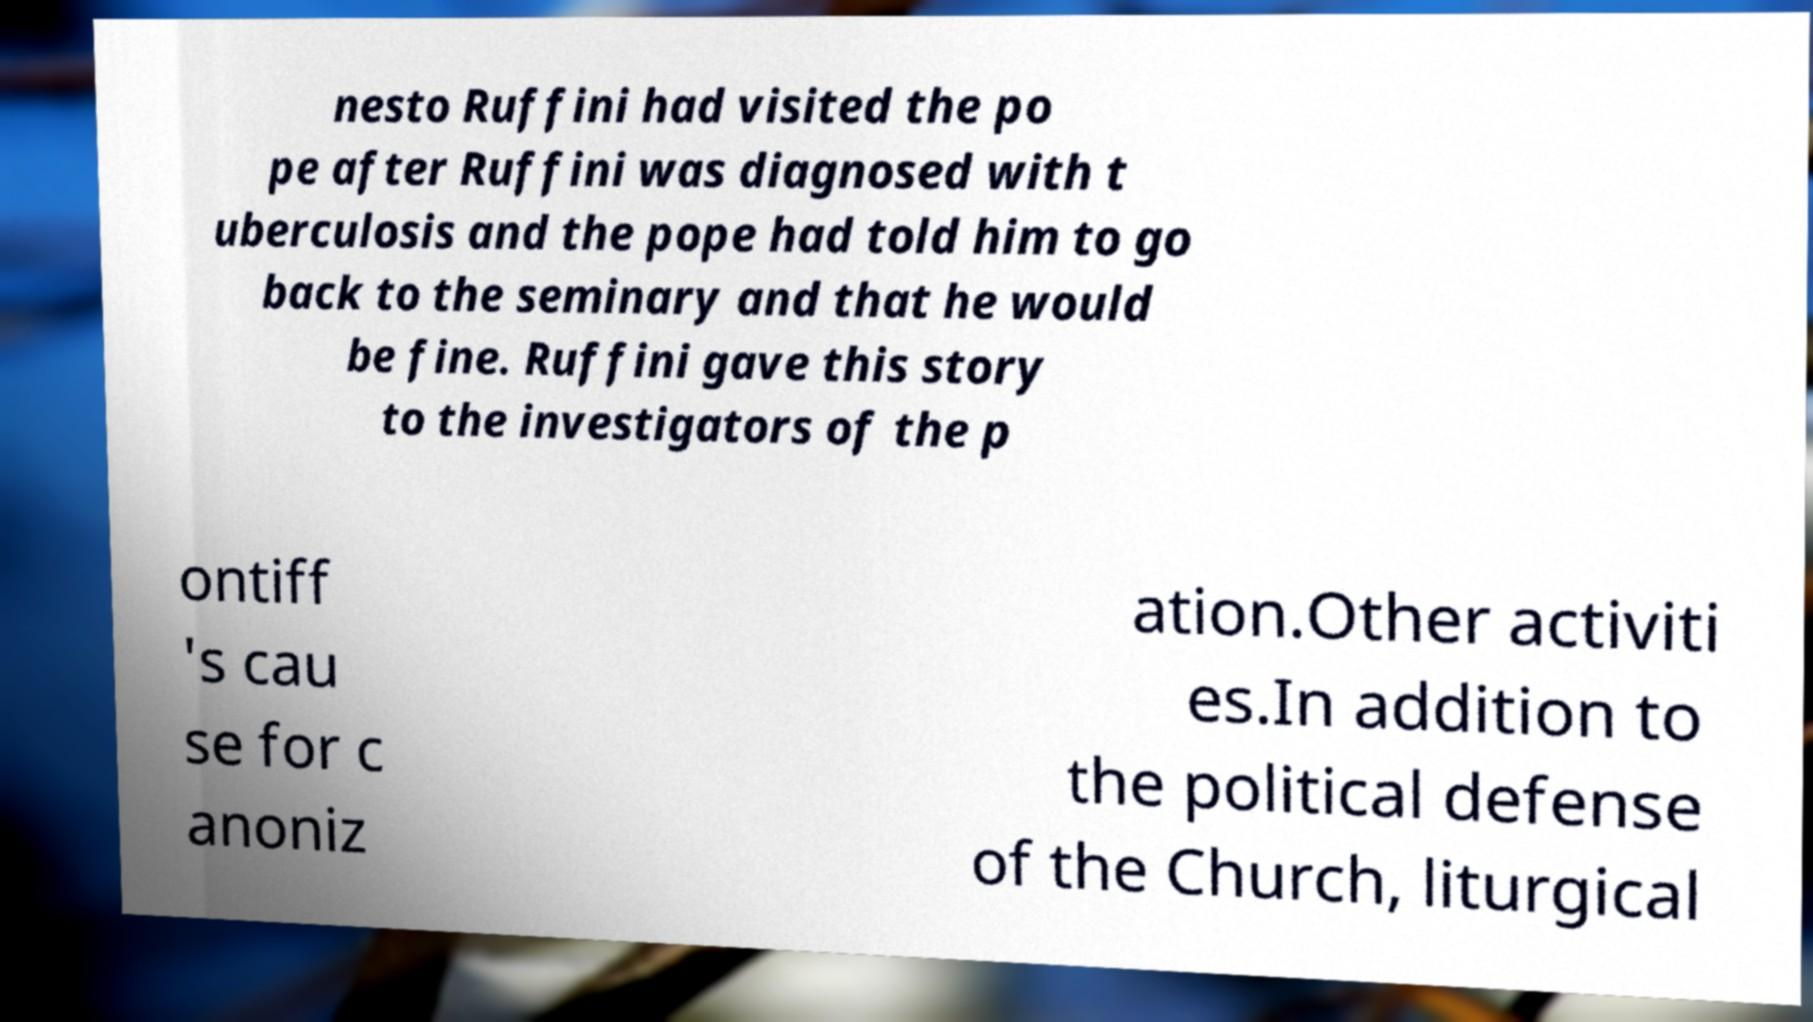Can you accurately transcribe the text from the provided image for me? nesto Ruffini had visited the po pe after Ruffini was diagnosed with t uberculosis and the pope had told him to go back to the seminary and that he would be fine. Ruffini gave this story to the investigators of the p ontiff 's cau se for c anoniz ation.Other activiti es.In addition to the political defense of the Church, liturgical 